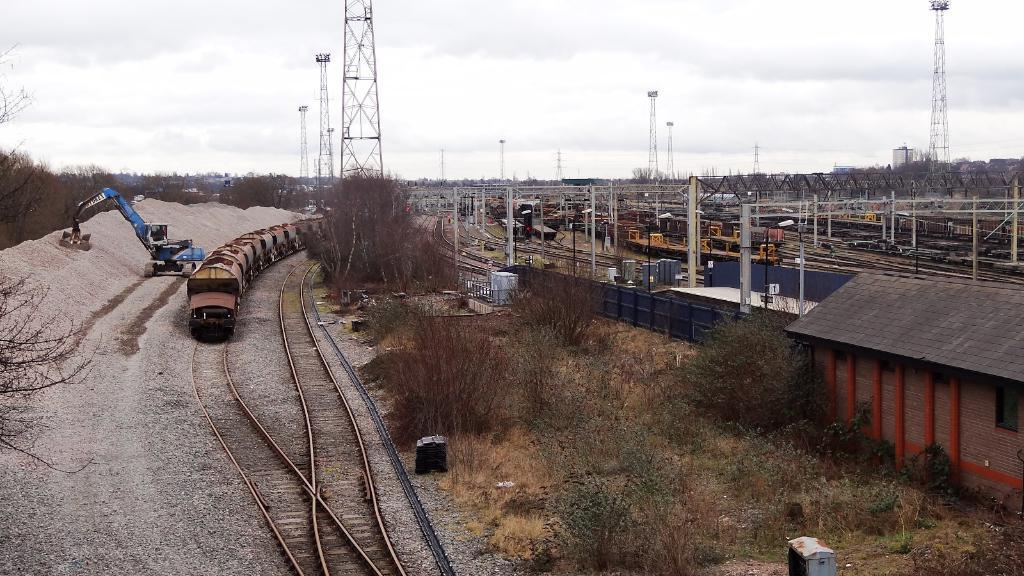What is the main subject of the image? The main subject of the image is a train on the track. Are there any other trains visible in the image? Yes, there are other trains on the tracks in the right corner. What is written above the trains? There are miles visible above the trains. What type of vegetation can be seen in the image? There are trees in the left corner of the image. What type of pain is the train experiencing in the image? There is no indication of pain in the image; it is a picture of a train on the track. What class is the train in the image? The image does not provide information about the class of the train. 